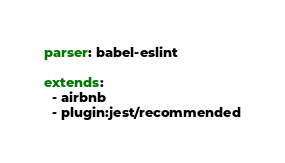<code> <loc_0><loc_0><loc_500><loc_500><_YAML_>parser: babel-eslint

extends:
  - airbnb
  - plugin:jest/recommended</code> 